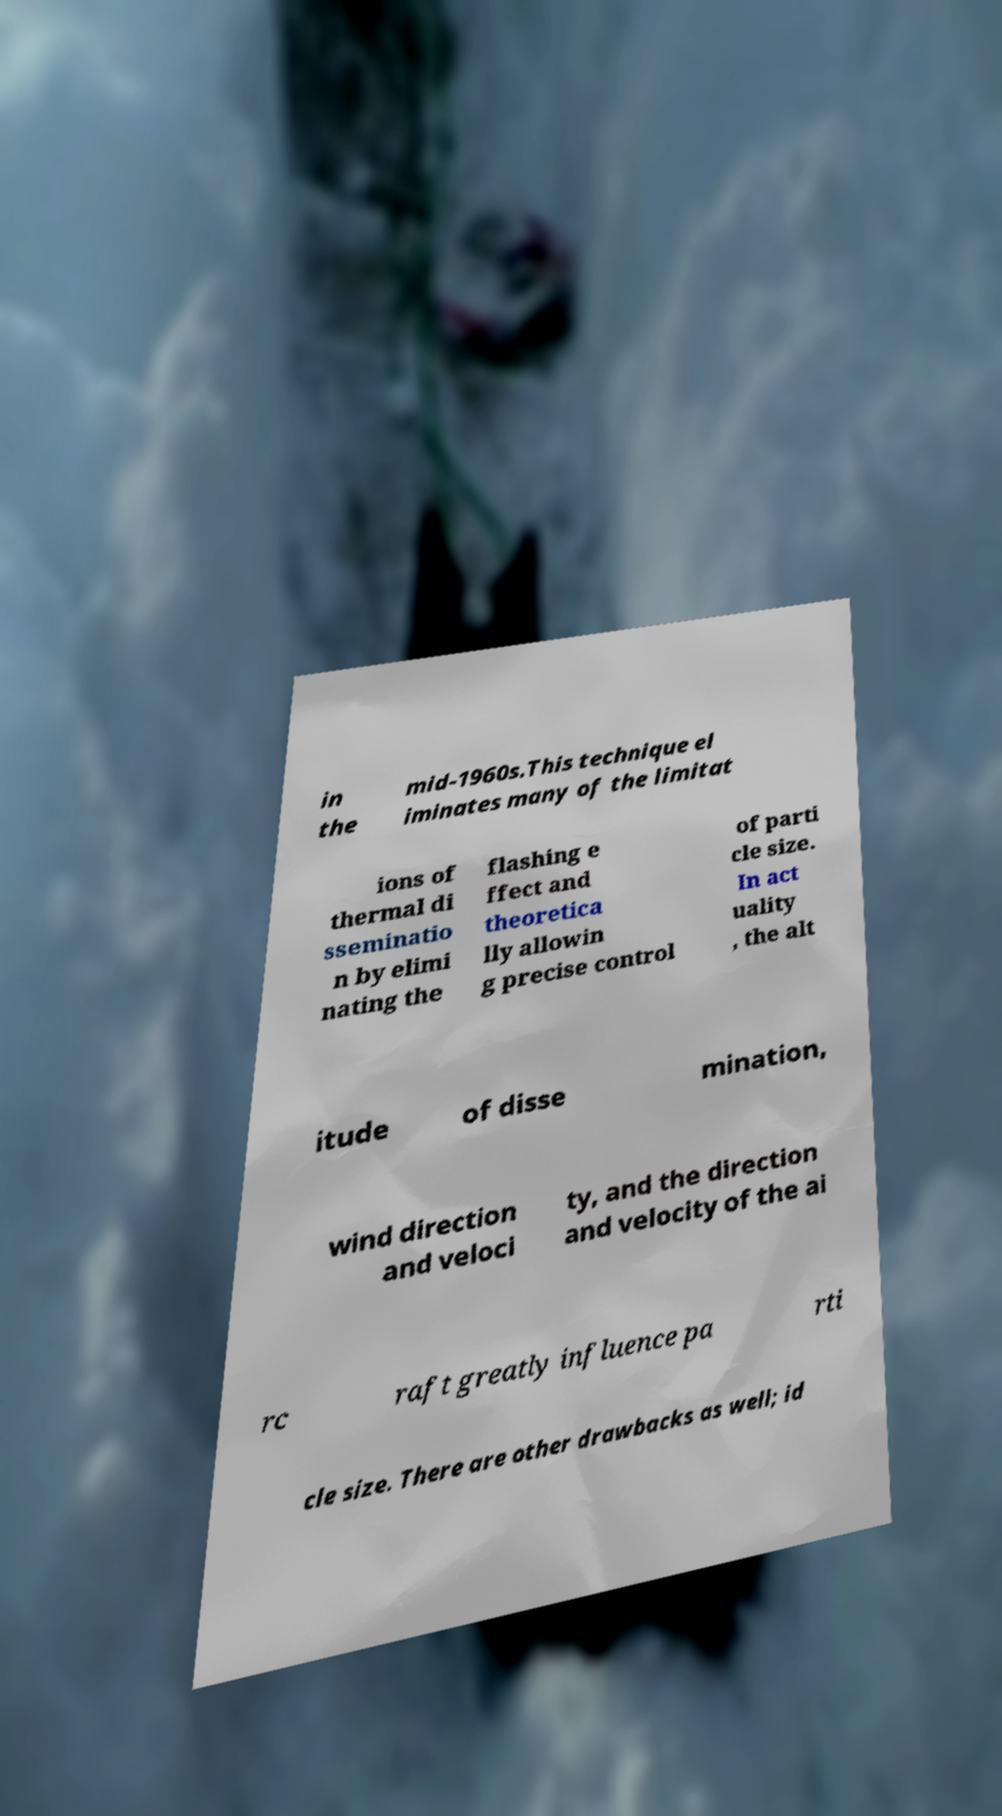Can you accurately transcribe the text from the provided image for me? in the mid-1960s.This technique el iminates many of the limitat ions of thermal di sseminatio n by elimi nating the flashing e ffect and theoretica lly allowin g precise control of parti cle size. In act uality , the alt itude of disse mination, wind direction and veloci ty, and the direction and velocity of the ai rc raft greatly influence pa rti cle size. There are other drawbacks as well; id 